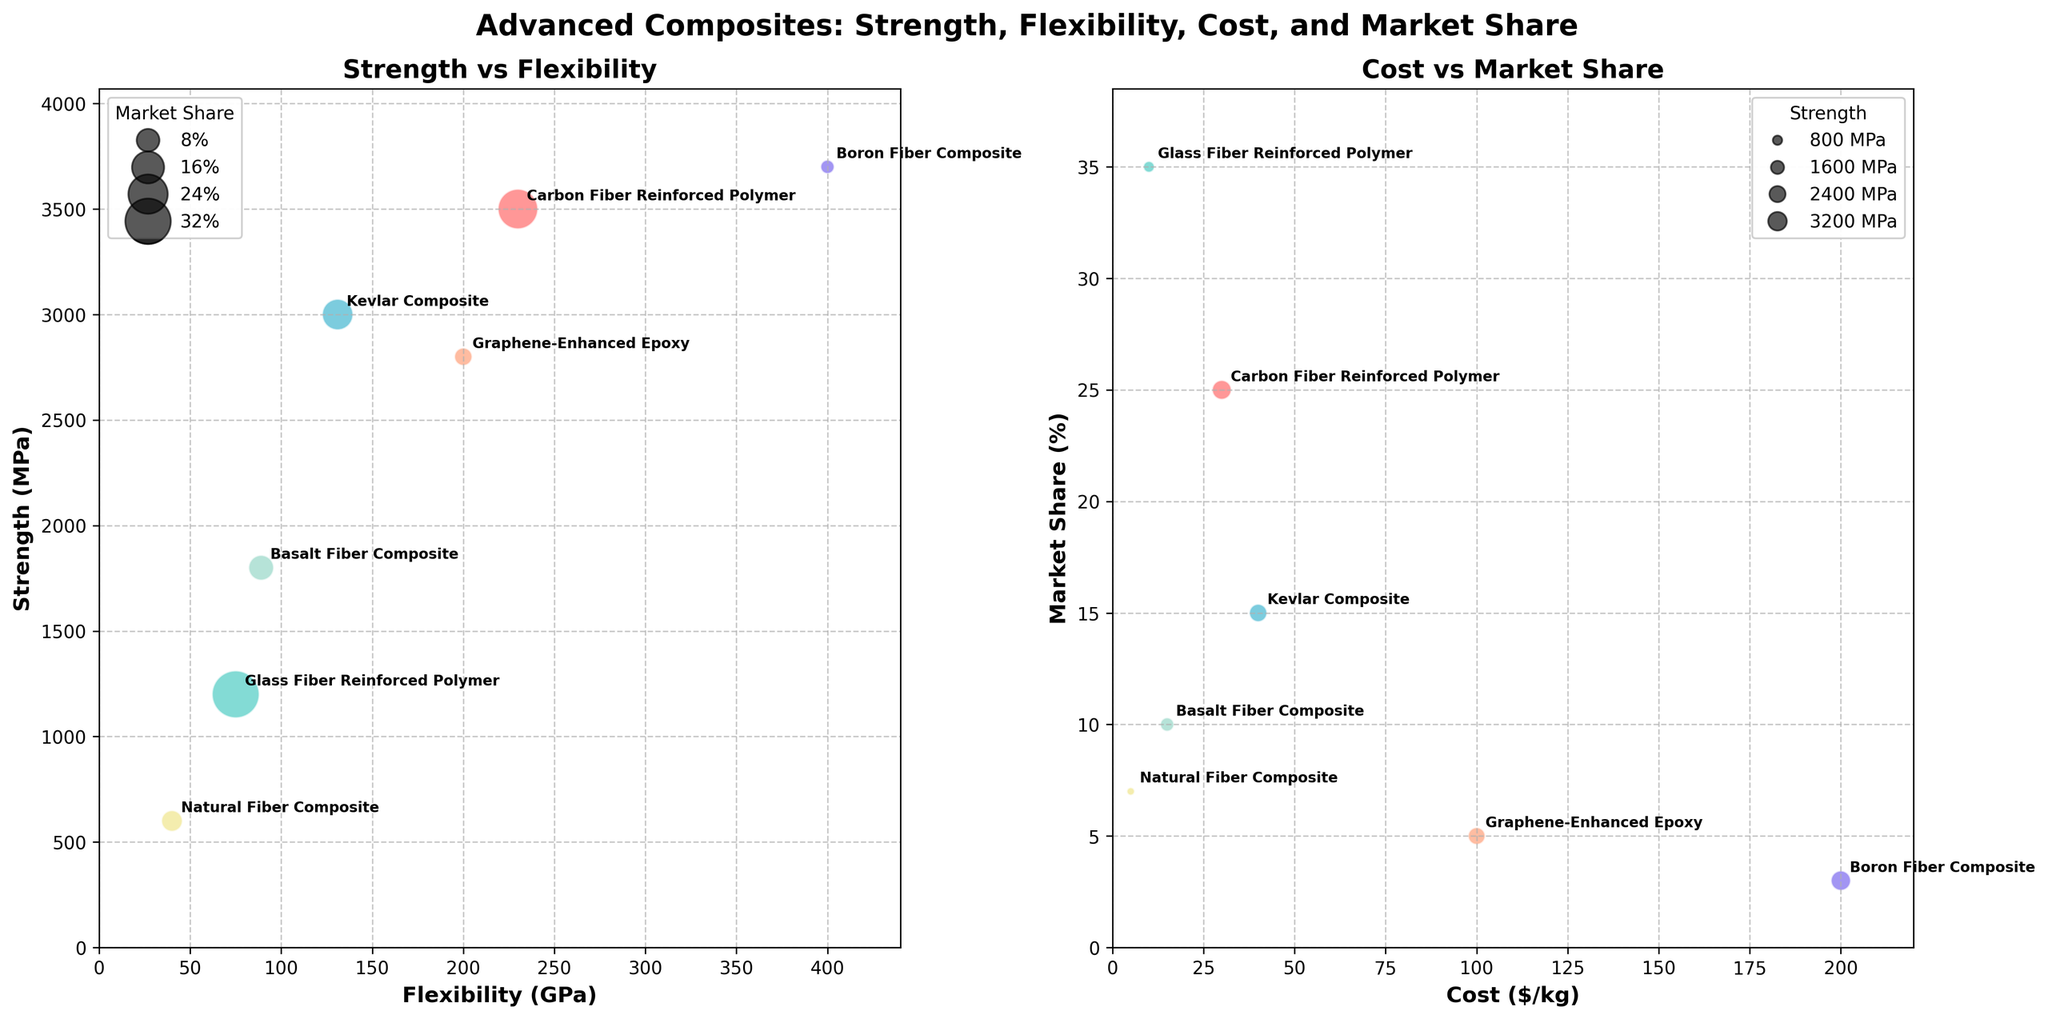what are the axes labels in the first subplot? The first subplot compares flexibility and strength of materials. The x-axis label is "Flexibility (GPa)" and the y-axis label is "Strength (MPa)."
Answer: Flexibility (GPa), Strength (MPa) Which material has the highest strength? To find the material with the highest strength, look for the data point with the highest y-value in the first subplot. This point represents Boron Fiber Composite with a strength of 3700 MPa.
Answer: Boron Fiber Composite How many materials have a market share greater than 10%? Examine the second subplot and count the bubbles whose y-values exceed 10% market share. Glass Fiber Reinforced Polymer, Carbon Fiber Reinforced Polymer, and Kevlar Composite all have market shares greater than 10%.
Answer: 3 Which material is the most flexible? Check the first subplot for the material with the highest x-value since flexibility is on the x-axis. Boron Fiber Composite has the highest flexibility at 400 GPa.
Answer: Boron Fiber Composite What’s the relationship between cost and market share for Carbon Fiber Reinforced Polymer? To determine the relationship for this material, locate its position in the second subplot. Carbon Fiber Reinforced Polymer has a cost of $30/kg and a market share of 25%.
Answer: $30/kg, 25% Which material offers the lowest cost and what is their market share? Look at the second subplot, focusing on the material with the smallest x-value. Natural Fiber Composite has the lowest cost at $5/kg and a market share of 7%.
Answer: Natural Fiber Composite, 7% Compare the flexibility of the Basalt Fiber Composite and Kevlar Composite. Which one is more flexible and by how much? Locate the two materials in the first subplot and compare their x-values. Basalt Fiber Composite has a flexibility of 89 GPa and Kevlar Composite has 131 GPa. Kevlar Composite is more flexible by 42 GPa.
Answer: Kevlar Composite, 42 GPa Which material has the least market share and what are its strength and flexibility values? Find the smallest bubble in the second subplot to identify the material with the least market share. Boron Fiber Composite has a market share of 3%, a strength of 3700 MPa, and flexibility of 400 GPa.
Answer: Boron Fiber Composite, 3700 MPa, 400 GPa Is there a trend between the flexibility and cost of the materials? Look across both subplots and note the positions associated with each metric. There seems to be a rough trend where more flexible materials (like Boron Fiber Composite) also tend to have higher costs.
Answer: Generally, more flexible materials are more expensive 